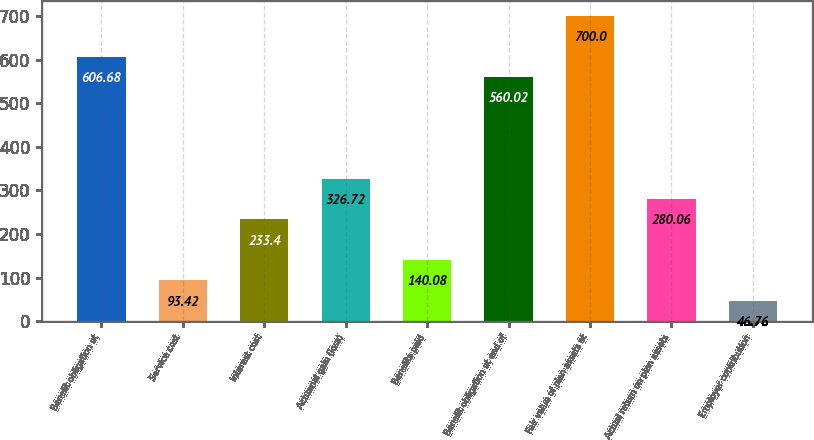Convert chart. <chart><loc_0><loc_0><loc_500><loc_500><bar_chart><fcel>Benefit obligation at<fcel>Service cost<fcel>Interest cost<fcel>Actuarial gain (loss)<fcel>Benefits paid<fcel>Benefit obligation at end of<fcel>Fair value of plan assets at<fcel>Actual return on plan assets<fcel>Employer contribution<nl><fcel>606.68<fcel>93.42<fcel>233.4<fcel>326.72<fcel>140.08<fcel>560.02<fcel>700<fcel>280.06<fcel>46.76<nl></chart> 